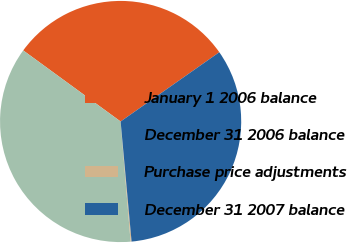Convert chart to OTSL. <chart><loc_0><loc_0><loc_500><loc_500><pie_chart><fcel>January 1 2006 balance<fcel>December 31 2006 balance<fcel>Purchase price adjustments<fcel>December 31 2007 balance<nl><fcel>30.22%<fcel>36.35%<fcel>0.13%<fcel>33.29%<nl></chart> 